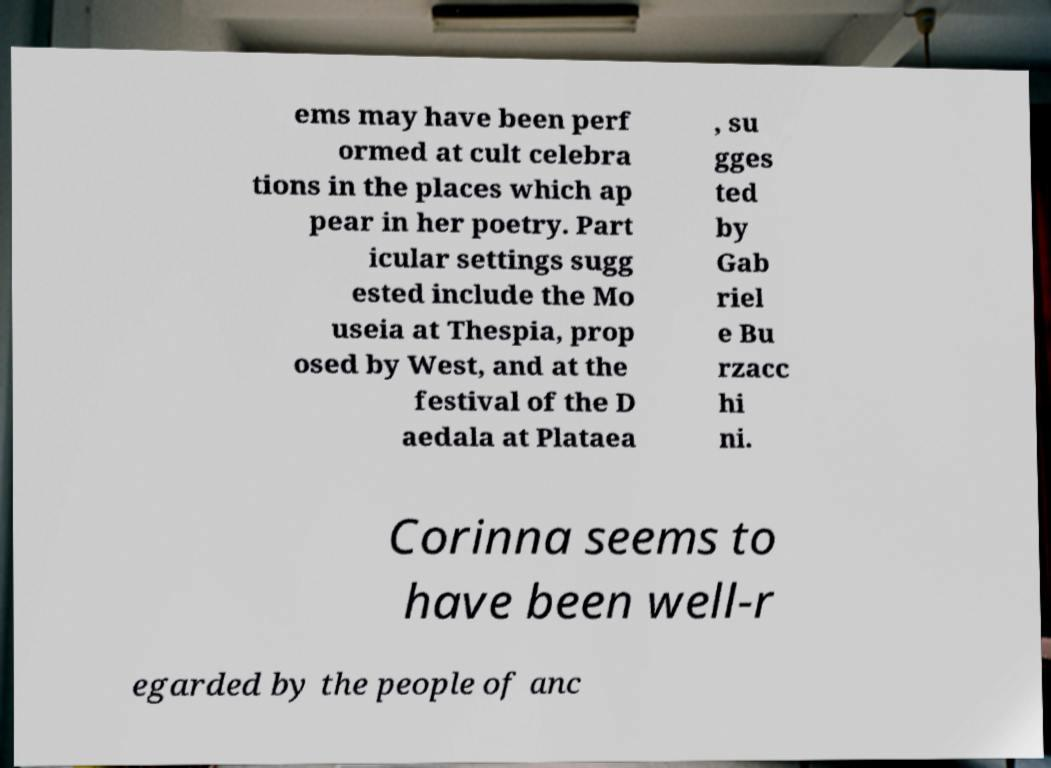Can you read and provide the text displayed in the image?This photo seems to have some interesting text. Can you extract and type it out for me? ems may have been perf ormed at cult celebra tions in the places which ap pear in her poetry. Part icular settings sugg ested include the Mo useia at Thespia, prop osed by West, and at the festival of the D aedala at Plataea , su gges ted by Gab riel e Bu rzacc hi ni. Corinna seems to have been well-r egarded by the people of anc 